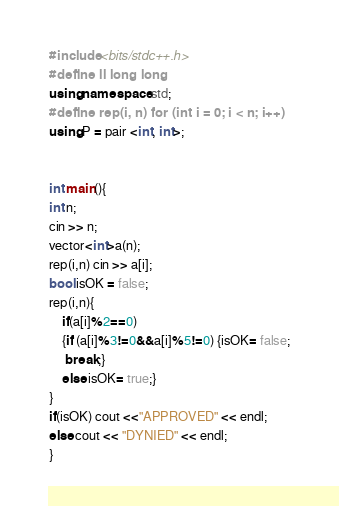Convert code to text. <code><loc_0><loc_0><loc_500><loc_500><_C++_>#include <bits/stdc++.h>
#define ll long long
using namespace std;
#define rep(i, n) for (int i = 0; i < n; i++)
using P = pair <int, int>;


int main(){
int n;
cin >> n;
vector<int>a(n);
rep(i,n) cin >> a[i];
bool isOK = false;
rep(i,n){
    if(a[i]%2==0)
    {if (a[i]%3!=0&&a[i]%5!=0) {isOK= false;
     break;}
    else isOK= true;}
} 
if(isOK) cout <<"APPROVED" << endl;
else cout << "DYNIED" << endl;
}  </code> 